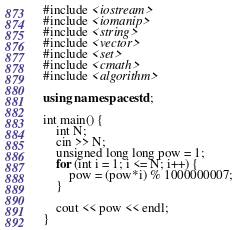Convert code to text. <code><loc_0><loc_0><loc_500><loc_500><_C++_>#include <iostream>
#include <iomanip>
#include <string>
#include <vector>
#include <set>
#include <cmath>
#include <algorithm>

using namespace std;

int main() {
	int N;
	cin >> N;
	unsigned long long pow = 1;
	for (int i = 1; i <= N; i++) {
		pow = (pow*i) % 1000000007;
	}

	cout << pow << endl;
}</code> 